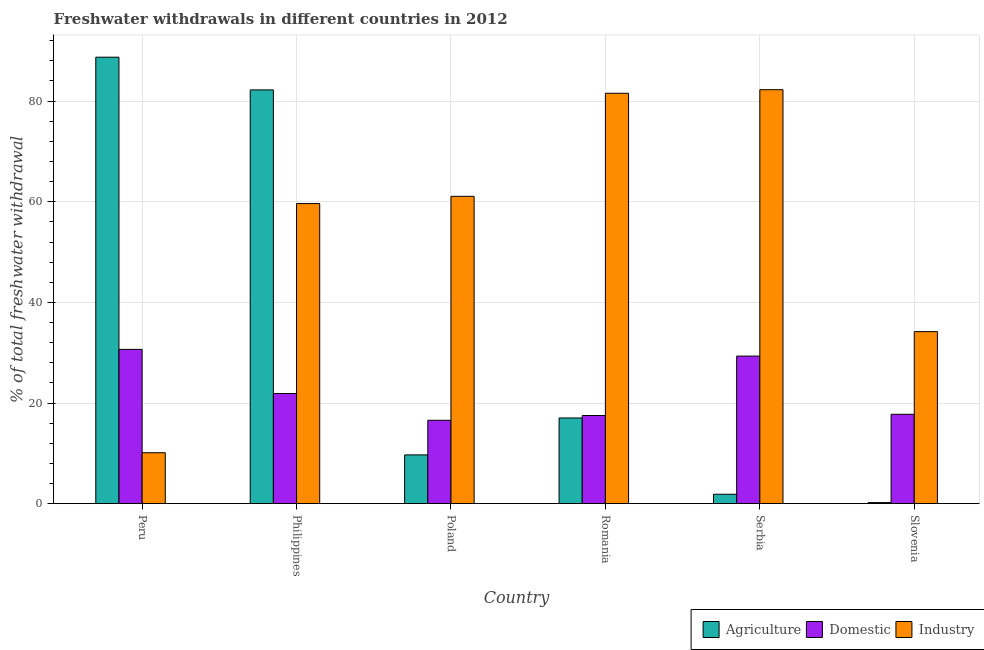Are the number of bars on each tick of the X-axis equal?
Your response must be concise. Yes. What is the label of the 2nd group of bars from the left?
Offer a terse response. Philippines. What is the percentage of freshwater withdrawal for domestic purposes in Peru?
Make the answer very short. 30.66. Across all countries, what is the maximum percentage of freshwater withdrawal for domestic purposes?
Your response must be concise. 30.66. Across all countries, what is the minimum percentage of freshwater withdrawal for domestic purposes?
Your answer should be very brief. 16.57. In which country was the percentage of freshwater withdrawal for domestic purposes maximum?
Ensure brevity in your answer.  Peru. In which country was the percentage of freshwater withdrawal for domestic purposes minimum?
Provide a short and direct response. Poland. What is the total percentage of freshwater withdrawal for domestic purposes in the graph?
Offer a very short reply. 133.73. What is the difference between the percentage of freshwater withdrawal for agriculture in Serbia and that in Slovenia?
Offer a very short reply. 1.66. What is the difference between the percentage of freshwater withdrawal for industry in Slovenia and the percentage of freshwater withdrawal for domestic purposes in Serbia?
Offer a terse response. 4.86. What is the average percentage of freshwater withdrawal for industry per country?
Make the answer very short. 54.81. What is the difference between the percentage of freshwater withdrawal for industry and percentage of freshwater withdrawal for agriculture in Peru?
Ensure brevity in your answer.  -78.61. In how many countries, is the percentage of freshwater withdrawal for domestic purposes greater than 52 %?
Keep it short and to the point. 0. What is the ratio of the percentage of freshwater withdrawal for agriculture in Poland to that in Romania?
Keep it short and to the point. 0.57. What is the difference between the highest and the second highest percentage of freshwater withdrawal for agriculture?
Give a very brief answer. 6.5. What is the difference between the highest and the lowest percentage of freshwater withdrawal for industry?
Provide a short and direct response. 72.15. In how many countries, is the percentage of freshwater withdrawal for domestic purposes greater than the average percentage of freshwater withdrawal for domestic purposes taken over all countries?
Provide a short and direct response. 2. Is the sum of the percentage of freshwater withdrawal for industry in Peru and Slovenia greater than the maximum percentage of freshwater withdrawal for agriculture across all countries?
Your answer should be compact. No. What does the 2nd bar from the left in Peru represents?
Provide a succinct answer. Domestic. What does the 1st bar from the right in Peru represents?
Offer a very short reply. Industry. Is it the case that in every country, the sum of the percentage of freshwater withdrawal for agriculture and percentage of freshwater withdrawal for domestic purposes is greater than the percentage of freshwater withdrawal for industry?
Keep it short and to the point. No. Are all the bars in the graph horizontal?
Ensure brevity in your answer.  No. Are the values on the major ticks of Y-axis written in scientific E-notation?
Your response must be concise. No. Does the graph contain any zero values?
Provide a short and direct response. No. Does the graph contain grids?
Your answer should be very brief. Yes. Where does the legend appear in the graph?
Keep it short and to the point. Bottom right. How many legend labels are there?
Offer a terse response. 3. What is the title of the graph?
Your response must be concise. Freshwater withdrawals in different countries in 2012. What is the label or title of the X-axis?
Give a very brief answer. Country. What is the label or title of the Y-axis?
Give a very brief answer. % of total freshwater withdrawal. What is the % of total freshwater withdrawal of Agriculture in Peru?
Offer a very short reply. 88.73. What is the % of total freshwater withdrawal of Domestic in Peru?
Your response must be concise. 30.66. What is the % of total freshwater withdrawal of Industry in Peru?
Give a very brief answer. 10.12. What is the % of total freshwater withdrawal of Agriculture in Philippines?
Offer a very short reply. 82.23. What is the % of total freshwater withdrawal of Domestic in Philippines?
Offer a terse response. 21.89. What is the % of total freshwater withdrawal of Industry in Philippines?
Provide a succinct answer. 59.64. What is the % of total freshwater withdrawal of Agriculture in Poland?
Offer a very short reply. 9.69. What is the % of total freshwater withdrawal of Domestic in Poland?
Provide a succinct answer. 16.57. What is the % of total freshwater withdrawal in Industry in Poland?
Provide a short and direct response. 61.08. What is the % of total freshwater withdrawal in Agriculture in Romania?
Your answer should be very brief. 17.03. What is the % of total freshwater withdrawal in Domestic in Romania?
Provide a short and direct response. 17.52. What is the % of total freshwater withdrawal in Industry in Romania?
Ensure brevity in your answer.  81.56. What is the % of total freshwater withdrawal in Agriculture in Serbia?
Your response must be concise. 1.87. What is the % of total freshwater withdrawal of Domestic in Serbia?
Keep it short and to the point. 29.33. What is the % of total freshwater withdrawal of Industry in Serbia?
Your answer should be compact. 82.27. What is the % of total freshwater withdrawal of Agriculture in Slovenia?
Keep it short and to the point. 0.21. What is the % of total freshwater withdrawal in Domestic in Slovenia?
Give a very brief answer. 17.76. What is the % of total freshwater withdrawal in Industry in Slovenia?
Provide a succinct answer. 34.19. Across all countries, what is the maximum % of total freshwater withdrawal of Agriculture?
Give a very brief answer. 88.73. Across all countries, what is the maximum % of total freshwater withdrawal of Domestic?
Offer a very short reply. 30.66. Across all countries, what is the maximum % of total freshwater withdrawal in Industry?
Provide a succinct answer. 82.27. Across all countries, what is the minimum % of total freshwater withdrawal of Agriculture?
Keep it short and to the point. 0.21. Across all countries, what is the minimum % of total freshwater withdrawal in Domestic?
Your answer should be very brief. 16.57. Across all countries, what is the minimum % of total freshwater withdrawal in Industry?
Provide a short and direct response. 10.12. What is the total % of total freshwater withdrawal in Agriculture in the graph?
Your response must be concise. 199.76. What is the total % of total freshwater withdrawal in Domestic in the graph?
Your answer should be compact. 133.73. What is the total % of total freshwater withdrawal of Industry in the graph?
Keep it short and to the point. 328.86. What is the difference between the % of total freshwater withdrawal of Agriculture in Peru and that in Philippines?
Give a very brief answer. 6.5. What is the difference between the % of total freshwater withdrawal of Domestic in Peru and that in Philippines?
Make the answer very short. 8.77. What is the difference between the % of total freshwater withdrawal in Industry in Peru and that in Philippines?
Give a very brief answer. -49.52. What is the difference between the % of total freshwater withdrawal of Agriculture in Peru and that in Poland?
Ensure brevity in your answer.  79.04. What is the difference between the % of total freshwater withdrawal in Domestic in Peru and that in Poland?
Provide a succinct answer. 14.09. What is the difference between the % of total freshwater withdrawal of Industry in Peru and that in Poland?
Offer a terse response. -50.96. What is the difference between the % of total freshwater withdrawal of Agriculture in Peru and that in Romania?
Offer a very short reply. 71.7. What is the difference between the % of total freshwater withdrawal of Domestic in Peru and that in Romania?
Provide a short and direct response. 13.14. What is the difference between the % of total freshwater withdrawal in Industry in Peru and that in Romania?
Your answer should be very brief. -71.44. What is the difference between the % of total freshwater withdrawal of Agriculture in Peru and that in Serbia?
Keep it short and to the point. 86.86. What is the difference between the % of total freshwater withdrawal of Domestic in Peru and that in Serbia?
Your answer should be very brief. 1.33. What is the difference between the % of total freshwater withdrawal of Industry in Peru and that in Serbia?
Your answer should be compact. -72.15. What is the difference between the % of total freshwater withdrawal in Agriculture in Peru and that in Slovenia?
Provide a short and direct response. 88.52. What is the difference between the % of total freshwater withdrawal of Industry in Peru and that in Slovenia?
Your answer should be very brief. -24.07. What is the difference between the % of total freshwater withdrawal of Agriculture in Philippines and that in Poland?
Provide a short and direct response. 72.54. What is the difference between the % of total freshwater withdrawal of Domestic in Philippines and that in Poland?
Ensure brevity in your answer.  5.32. What is the difference between the % of total freshwater withdrawal in Industry in Philippines and that in Poland?
Provide a succinct answer. -1.44. What is the difference between the % of total freshwater withdrawal in Agriculture in Philippines and that in Romania?
Your answer should be very brief. 65.2. What is the difference between the % of total freshwater withdrawal of Domestic in Philippines and that in Romania?
Give a very brief answer. 4.37. What is the difference between the % of total freshwater withdrawal of Industry in Philippines and that in Romania?
Keep it short and to the point. -21.92. What is the difference between the % of total freshwater withdrawal of Agriculture in Philippines and that in Serbia?
Offer a very short reply. 80.36. What is the difference between the % of total freshwater withdrawal in Domestic in Philippines and that in Serbia?
Ensure brevity in your answer.  -7.44. What is the difference between the % of total freshwater withdrawal in Industry in Philippines and that in Serbia?
Your answer should be very brief. -22.63. What is the difference between the % of total freshwater withdrawal in Agriculture in Philippines and that in Slovenia?
Your response must be concise. 82.02. What is the difference between the % of total freshwater withdrawal in Domestic in Philippines and that in Slovenia?
Offer a very short reply. 4.13. What is the difference between the % of total freshwater withdrawal in Industry in Philippines and that in Slovenia?
Your answer should be very brief. 25.45. What is the difference between the % of total freshwater withdrawal in Agriculture in Poland and that in Romania?
Your answer should be compact. -7.34. What is the difference between the % of total freshwater withdrawal in Domestic in Poland and that in Romania?
Make the answer very short. -0.95. What is the difference between the % of total freshwater withdrawal of Industry in Poland and that in Romania?
Provide a short and direct response. -20.48. What is the difference between the % of total freshwater withdrawal of Agriculture in Poland and that in Serbia?
Make the answer very short. 7.82. What is the difference between the % of total freshwater withdrawal in Domestic in Poland and that in Serbia?
Your answer should be very brief. -12.76. What is the difference between the % of total freshwater withdrawal in Industry in Poland and that in Serbia?
Offer a very short reply. -21.19. What is the difference between the % of total freshwater withdrawal of Agriculture in Poland and that in Slovenia?
Keep it short and to the point. 9.48. What is the difference between the % of total freshwater withdrawal in Domestic in Poland and that in Slovenia?
Ensure brevity in your answer.  -1.19. What is the difference between the % of total freshwater withdrawal in Industry in Poland and that in Slovenia?
Your response must be concise. 26.89. What is the difference between the % of total freshwater withdrawal in Agriculture in Romania and that in Serbia?
Ensure brevity in your answer.  15.16. What is the difference between the % of total freshwater withdrawal in Domestic in Romania and that in Serbia?
Make the answer very short. -11.81. What is the difference between the % of total freshwater withdrawal of Industry in Romania and that in Serbia?
Your response must be concise. -0.71. What is the difference between the % of total freshwater withdrawal in Agriculture in Romania and that in Slovenia?
Give a very brief answer. 16.82. What is the difference between the % of total freshwater withdrawal of Domestic in Romania and that in Slovenia?
Your response must be concise. -0.24. What is the difference between the % of total freshwater withdrawal in Industry in Romania and that in Slovenia?
Provide a short and direct response. 47.37. What is the difference between the % of total freshwater withdrawal of Agriculture in Serbia and that in Slovenia?
Ensure brevity in your answer.  1.66. What is the difference between the % of total freshwater withdrawal in Domestic in Serbia and that in Slovenia?
Offer a terse response. 11.57. What is the difference between the % of total freshwater withdrawal of Industry in Serbia and that in Slovenia?
Offer a terse response. 48.08. What is the difference between the % of total freshwater withdrawal in Agriculture in Peru and the % of total freshwater withdrawal in Domestic in Philippines?
Keep it short and to the point. 66.84. What is the difference between the % of total freshwater withdrawal of Agriculture in Peru and the % of total freshwater withdrawal of Industry in Philippines?
Keep it short and to the point. 29.09. What is the difference between the % of total freshwater withdrawal in Domestic in Peru and the % of total freshwater withdrawal in Industry in Philippines?
Your answer should be compact. -28.98. What is the difference between the % of total freshwater withdrawal of Agriculture in Peru and the % of total freshwater withdrawal of Domestic in Poland?
Offer a terse response. 72.16. What is the difference between the % of total freshwater withdrawal of Agriculture in Peru and the % of total freshwater withdrawal of Industry in Poland?
Keep it short and to the point. 27.65. What is the difference between the % of total freshwater withdrawal in Domestic in Peru and the % of total freshwater withdrawal in Industry in Poland?
Your answer should be compact. -30.42. What is the difference between the % of total freshwater withdrawal in Agriculture in Peru and the % of total freshwater withdrawal in Domestic in Romania?
Offer a very short reply. 71.21. What is the difference between the % of total freshwater withdrawal in Agriculture in Peru and the % of total freshwater withdrawal in Industry in Romania?
Your response must be concise. 7.17. What is the difference between the % of total freshwater withdrawal in Domestic in Peru and the % of total freshwater withdrawal in Industry in Romania?
Offer a terse response. -50.9. What is the difference between the % of total freshwater withdrawal of Agriculture in Peru and the % of total freshwater withdrawal of Domestic in Serbia?
Ensure brevity in your answer.  59.4. What is the difference between the % of total freshwater withdrawal in Agriculture in Peru and the % of total freshwater withdrawal in Industry in Serbia?
Offer a terse response. 6.46. What is the difference between the % of total freshwater withdrawal in Domestic in Peru and the % of total freshwater withdrawal in Industry in Serbia?
Provide a short and direct response. -51.61. What is the difference between the % of total freshwater withdrawal in Agriculture in Peru and the % of total freshwater withdrawal in Domestic in Slovenia?
Offer a terse response. 70.97. What is the difference between the % of total freshwater withdrawal in Agriculture in Peru and the % of total freshwater withdrawal in Industry in Slovenia?
Make the answer very short. 54.54. What is the difference between the % of total freshwater withdrawal of Domestic in Peru and the % of total freshwater withdrawal of Industry in Slovenia?
Offer a terse response. -3.53. What is the difference between the % of total freshwater withdrawal in Agriculture in Philippines and the % of total freshwater withdrawal in Domestic in Poland?
Give a very brief answer. 65.66. What is the difference between the % of total freshwater withdrawal of Agriculture in Philippines and the % of total freshwater withdrawal of Industry in Poland?
Keep it short and to the point. 21.15. What is the difference between the % of total freshwater withdrawal of Domestic in Philippines and the % of total freshwater withdrawal of Industry in Poland?
Offer a terse response. -39.19. What is the difference between the % of total freshwater withdrawal in Agriculture in Philippines and the % of total freshwater withdrawal in Domestic in Romania?
Provide a short and direct response. 64.71. What is the difference between the % of total freshwater withdrawal in Agriculture in Philippines and the % of total freshwater withdrawal in Industry in Romania?
Provide a short and direct response. 0.67. What is the difference between the % of total freshwater withdrawal of Domestic in Philippines and the % of total freshwater withdrawal of Industry in Romania?
Offer a very short reply. -59.67. What is the difference between the % of total freshwater withdrawal of Agriculture in Philippines and the % of total freshwater withdrawal of Domestic in Serbia?
Provide a succinct answer. 52.9. What is the difference between the % of total freshwater withdrawal of Agriculture in Philippines and the % of total freshwater withdrawal of Industry in Serbia?
Offer a very short reply. -0.04. What is the difference between the % of total freshwater withdrawal of Domestic in Philippines and the % of total freshwater withdrawal of Industry in Serbia?
Offer a very short reply. -60.38. What is the difference between the % of total freshwater withdrawal in Agriculture in Philippines and the % of total freshwater withdrawal in Domestic in Slovenia?
Give a very brief answer. 64.47. What is the difference between the % of total freshwater withdrawal of Agriculture in Philippines and the % of total freshwater withdrawal of Industry in Slovenia?
Offer a terse response. 48.04. What is the difference between the % of total freshwater withdrawal of Agriculture in Poland and the % of total freshwater withdrawal of Domestic in Romania?
Give a very brief answer. -7.83. What is the difference between the % of total freshwater withdrawal in Agriculture in Poland and the % of total freshwater withdrawal in Industry in Romania?
Your response must be concise. -71.87. What is the difference between the % of total freshwater withdrawal of Domestic in Poland and the % of total freshwater withdrawal of Industry in Romania?
Give a very brief answer. -64.99. What is the difference between the % of total freshwater withdrawal of Agriculture in Poland and the % of total freshwater withdrawal of Domestic in Serbia?
Your response must be concise. -19.64. What is the difference between the % of total freshwater withdrawal in Agriculture in Poland and the % of total freshwater withdrawal in Industry in Serbia?
Provide a short and direct response. -72.58. What is the difference between the % of total freshwater withdrawal of Domestic in Poland and the % of total freshwater withdrawal of Industry in Serbia?
Provide a succinct answer. -65.7. What is the difference between the % of total freshwater withdrawal in Agriculture in Poland and the % of total freshwater withdrawal in Domestic in Slovenia?
Offer a terse response. -8.07. What is the difference between the % of total freshwater withdrawal of Agriculture in Poland and the % of total freshwater withdrawal of Industry in Slovenia?
Provide a short and direct response. -24.5. What is the difference between the % of total freshwater withdrawal in Domestic in Poland and the % of total freshwater withdrawal in Industry in Slovenia?
Make the answer very short. -17.62. What is the difference between the % of total freshwater withdrawal in Agriculture in Romania and the % of total freshwater withdrawal in Industry in Serbia?
Your answer should be very brief. -65.24. What is the difference between the % of total freshwater withdrawal in Domestic in Romania and the % of total freshwater withdrawal in Industry in Serbia?
Provide a succinct answer. -64.75. What is the difference between the % of total freshwater withdrawal of Agriculture in Romania and the % of total freshwater withdrawal of Domestic in Slovenia?
Your response must be concise. -0.73. What is the difference between the % of total freshwater withdrawal of Agriculture in Romania and the % of total freshwater withdrawal of Industry in Slovenia?
Offer a very short reply. -17.16. What is the difference between the % of total freshwater withdrawal of Domestic in Romania and the % of total freshwater withdrawal of Industry in Slovenia?
Ensure brevity in your answer.  -16.67. What is the difference between the % of total freshwater withdrawal in Agriculture in Serbia and the % of total freshwater withdrawal in Domestic in Slovenia?
Provide a short and direct response. -15.89. What is the difference between the % of total freshwater withdrawal of Agriculture in Serbia and the % of total freshwater withdrawal of Industry in Slovenia?
Provide a short and direct response. -32.32. What is the difference between the % of total freshwater withdrawal in Domestic in Serbia and the % of total freshwater withdrawal in Industry in Slovenia?
Offer a very short reply. -4.86. What is the average % of total freshwater withdrawal of Agriculture per country?
Your response must be concise. 33.29. What is the average % of total freshwater withdrawal in Domestic per country?
Your response must be concise. 22.29. What is the average % of total freshwater withdrawal in Industry per country?
Provide a short and direct response. 54.81. What is the difference between the % of total freshwater withdrawal in Agriculture and % of total freshwater withdrawal in Domestic in Peru?
Your response must be concise. 58.07. What is the difference between the % of total freshwater withdrawal of Agriculture and % of total freshwater withdrawal of Industry in Peru?
Offer a very short reply. 78.61. What is the difference between the % of total freshwater withdrawal in Domestic and % of total freshwater withdrawal in Industry in Peru?
Give a very brief answer. 20.54. What is the difference between the % of total freshwater withdrawal in Agriculture and % of total freshwater withdrawal in Domestic in Philippines?
Give a very brief answer. 60.34. What is the difference between the % of total freshwater withdrawal of Agriculture and % of total freshwater withdrawal of Industry in Philippines?
Keep it short and to the point. 22.59. What is the difference between the % of total freshwater withdrawal of Domestic and % of total freshwater withdrawal of Industry in Philippines?
Provide a short and direct response. -37.75. What is the difference between the % of total freshwater withdrawal in Agriculture and % of total freshwater withdrawal in Domestic in Poland?
Offer a terse response. -6.88. What is the difference between the % of total freshwater withdrawal in Agriculture and % of total freshwater withdrawal in Industry in Poland?
Give a very brief answer. -51.39. What is the difference between the % of total freshwater withdrawal of Domestic and % of total freshwater withdrawal of Industry in Poland?
Your answer should be very brief. -44.51. What is the difference between the % of total freshwater withdrawal of Agriculture and % of total freshwater withdrawal of Domestic in Romania?
Your response must be concise. -0.49. What is the difference between the % of total freshwater withdrawal of Agriculture and % of total freshwater withdrawal of Industry in Romania?
Your answer should be compact. -64.53. What is the difference between the % of total freshwater withdrawal of Domestic and % of total freshwater withdrawal of Industry in Romania?
Keep it short and to the point. -64.04. What is the difference between the % of total freshwater withdrawal of Agriculture and % of total freshwater withdrawal of Domestic in Serbia?
Ensure brevity in your answer.  -27.46. What is the difference between the % of total freshwater withdrawal in Agriculture and % of total freshwater withdrawal in Industry in Serbia?
Your response must be concise. -80.4. What is the difference between the % of total freshwater withdrawal in Domestic and % of total freshwater withdrawal in Industry in Serbia?
Ensure brevity in your answer.  -52.94. What is the difference between the % of total freshwater withdrawal of Agriculture and % of total freshwater withdrawal of Domestic in Slovenia?
Ensure brevity in your answer.  -17.55. What is the difference between the % of total freshwater withdrawal of Agriculture and % of total freshwater withdrawal of Industry in Slovenia?
Offer a very short reply. -33.98. What is the difference between the % of total freshwater withdrawal of Domestic and % of total freshwater withdrawal of Industry in Slovenia?
Provide a short and direct response. -16.43. What is the ratio of the % of total freshwater withdrawal in Agriculture in Peru to that in Philippines?
Your answer should be compact. 1.08. What is the ratio of the % of total freshwater withdrawal of Domestic in Peru to that in Philippines?
Provide a short and direct response. 1.4. What is the ratio of the % of total freshwater withdrawal of Industry in Peru to that in Philippines?
Your answer should be compact. 0.17. What is the ratio of the % of total freshwater withdrawal of Agriculture in Peru to that in Poland?
Provide a short and direct response. 9.16. What is the ratio of the % of total freshwater withdrawal in Domestic in Peru to that in Poland?
Offer a very short reply. 1.85. What is the ratio of the % of total freshwater withdrawal of Industry in Peru to that in Poland?
Provide a short and direct response. 0.17. What is the ratio of the % of total freshwater withdrawal of Agriculture in Peru to that in Romania?
Offer a very short reply. 5.21. What is the ratio of the % of total freshwater withdrawal in Domestic in Peru to that in Romania?
Give a very brief answer. 1.75. What is the ratio of the % of total freshwater withdrawal of Industry in Peru to that in Romania?
Provide a short and direct response. 0.12. What is the ratio of the % of total freshwater withdrawal in Agriculture in Peru to that in Serbia?
Offer a very short reply. 47.5. What is the ratio of the % of total freshwater withdrawal of Domestic in Peru to that in Serbia?
Ensure brevity in your answer.  1.05. What is the ratio of the % of total freshwater withdrawal in Industry in Peru to that in Serbia?
Your answer should be compact. 0.12. What is the ratio of the % of total freshwater withdrawal in Agriculture in Peru to that in Slovenia?
Offer a terse response. 417.95. What is the ratio of the % of total freshwater withdrawal of Domestic in Peru to that in Slovenia?
Ensure brevity in your answer.  1.73. What is the ratio of the % of total freshwater withdrawal in Industry in Peru to that in Slovenia?
Provide a succinct answer. 0.3. What is the ratio of the % of total freshwater withdrawal of Agriculture in Philippines to that in Poland?
Make the answer very short. 8.49. What is the ratio of the % of total freshwater withdrawal of Domestic in Philippines to that in Poland?
Your answer should be very brief. 1.32. What is the ratio of the % of total freshwater withdrawal in Industry in Philippines to that in Poland?
Make the answer very short. 0.98. What is the ratio of the % of total freshwater withdrawal in Agriculture in Philippines to that in Romania?
Give a very brief answer. 4.83. What is the ratio of the % of total freshwater withdrawal in Domestic in Philippines to that in Romania?
Your answer should be compact. 1.25. What is the ratio of the % of total freshwater withdrawal of Industry in Philippines to that in Romania?
Give a very brief answer. 0.73. What is the ratio of the % of total freshwater withdrawal in Agriculture in Philippines to that in Serbia?
Provide a succinct answer. 44.02. What is the ratio of the % of total freshwater withdrawal in Domestic in Philippines to that in Serbia?
Your answer should be compact. 0.75. What is the ratio of the % of total freshwater withdrawal of Industry in Philippines to that in Serbia?
Keep it short and to the point. 0.72. What is the ratio of the % of total freshwater withdrawal of Agriculture in Philippines to that in Slovenia?
Provide a short and direct response. 387.33. What is the ratio of the % of total freshwater withdrawal of Domestic in Philippines to that in Slovenia?
Provide a short and direct response. 1.23. What is the ratio of the % of total freshwater withdrawal in Industry in Philippines to that in Slovenia?
Ensure brevity in your answer.  1.74. What is the ratio of the % of total freshwater withdrawal in Agriculture in Poland to that in Romania?
Your answer should be compact. 0.57. What is the ratio of the % of total freshwater withdrawal in Domestic in Poland to that in Romania?
Provide a succinct answer. 0.95. What is the ratio of the % of total freshwater withdrawal of Industry in Poland to that in Romania?
Your answer should be compact. 0.75. What is the ratio of the % of total freshwater withdrawal in Agriculture in Poland to that in Serbia?
Offer a very short reply. 5.19. What is the ratio of the % of total freshwater withdrawal in Domestic in Poland to that in Serbia?
Make the answer very short. 0.56. What is the ratio of the % of total freshwater withdrawal of Industry in Poland to that in Serbia?
Your response must be concise. 0.74. What is the ratio of the % of total freshwater withdrawal of Agriculture in Poland to that in Slovenia?
Keep it short and to the point. 45.65. What is the ratio of the % of total freshwater withdrawal of Domestic in Poland to that in Slovenia?
Ensure brevity in your answer.  0.93. What is the ratio of the % of total freshwater withdrawal in Industry in Poland to that in Slovenia?
Provide a succinct answer. 1.79. What is the ratio of the % of total freshwater withdrawal in Agriculture in Romania to that in Serbia?
Keep it short and to the point. 9.12. What is the ratio of the % of total freshwater withdrawal of Domestic in Romania to that in Serbia?
Your response must be concise. 0.6. What is the ratio of the % of total freshwater withdrawal in Industry in Romania to that in Serbia?
Keep it short and to the point. 0.99. What is the ratio of the % of total freshwater withdrawal in Agriculture in Romania to that in Slovenia?
Your answer should be very brief. 80.22. What is the ratio of the % of total freshwater withdrawal of Domestic in Romania to that in Slovenia?
Your answer should be very brief. 0.99. What is the ratio of the % of total freshwater withdrawal of Industry in Romania to that in Slovenia?
Your answer should be very brief. 2.39. What is the ratio of the % of total freshwater withdrawal of Agriculture in Serbia to that in Slovenia?
Keep it short and to the point. 8.8. What is the ratio of the % of total freshwater withdrawal in Domestic in Serbia to that in Slovenia?
Give a very brief answer. 1.65. What is the ratio of the % of total freshwater withdrawal in Industry in Serbia to that in Slovenia?
Offer a terse response. 2.41. What is the difference between the highest and the second highest % of total freshwater withdrawal in Domestic?
Give a very brief answer. 1.33. What is the difference between the highest and the second highest % of total freshwater withdrawal of Industry?
Give a very brief answer. 0.71. What is the difference between the highest and the lowest % of total freshwater withdrawal of Agriculture?
Offer a very short reply. 88.52. What is the difference between the highest and the lowest % of total freshwater withdrawal of Domestic?
Make the answer very short. 14.09. What is the difference between the highest and the lowest % of total freshwater withdrawal of Industry?
Your answer should be very brief. 72.15. 